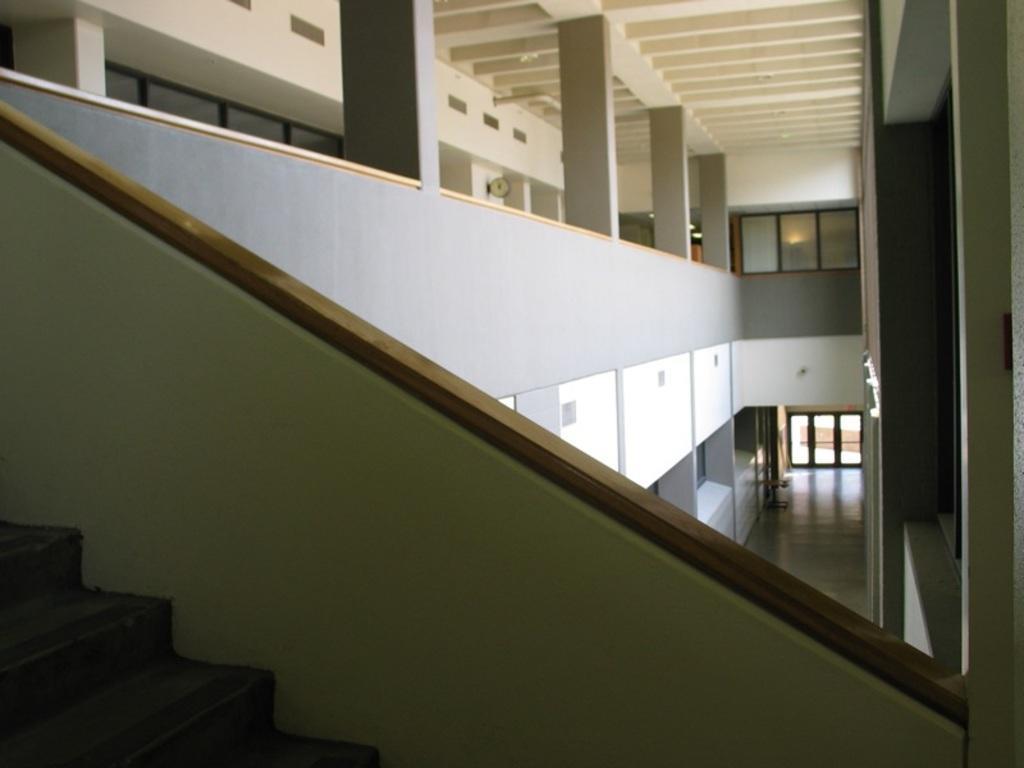In one or two sentences, can you explain what this image depicts? In this picture i can see the inside view of the building. At the bottom there are stairs. In the background i can see the windows and doors. On the left there are pillars. On the right i can see the tube lights on the wall. 